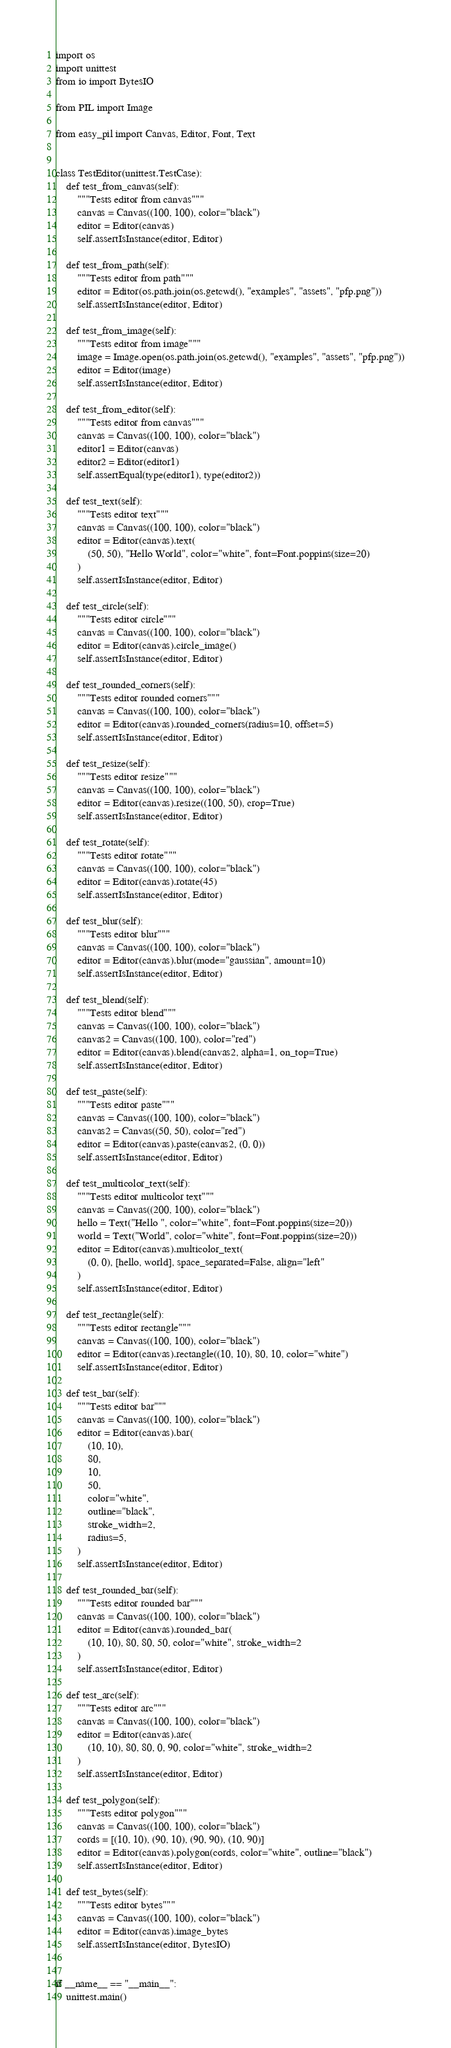Convert code to text. <code><loc_0><loc_0><loc_500><loc_500><_Python_>import os
import unittest
from io import BytesIO

from PIL import Image

from easy_pil import Canvas, Editor, Font, Text


class TestEditor(unittest.TestCase):
    def test_from_canvas(self):
        """Tests editor from canvas"""
        canvas = Canvas((100, 100), color="black")
        editor = Editor(canvas)
        self.assertIsInstance(editor, Editor)

    def test_from_path(self):
        """Tests editor from path"""
        editor = Editor(os.path.join(os.getcwd(), "examples", "assets", "pfp.png"))
        self.assertIsInstance(editor, Editor)

    def test_from_image(self):
        """Tests editor from image"""
        image = Image.open(os.path.join(os.getcwd(), "examples", "assets", "pfp.png"))
        editor = Editor(image)
        self.assertIsInstance(editor, Editor)

    def test_from_editor(self):
        """Tests editor from canvas"""
        canvas = Canvas((100, 100), color="black")
        editor1 = Editor(canvas)
        editor2 = Editor(editor1)
        self.assertEqual(type(editor1), type(editor2))

    def test_text(self):
        """Tests editor text"""
        canvas = Canvas((100, 100), color="black")
        editor = Editor(canvas).text(
            (50, 50), "Hello World", color="white", font=Font.poppins(size=20)
        )
        self.assertIsInstance(editor, Editor)

    def test_circle(self):
        """Tests editor circle"""
        canvas = Canvas((100, 100), color="black")
        editor = Editor(canvas).circle_image()
        self.assertIsInstance(editor, Editor)

    def test_rounded_corners(self):
        """Tests editor rounded corners"""
        canvas = Canvas((100, 100), color="black")
        editor = Editor(canvas).rounded_corners(radius=10, offset=5)
        self.assertIsInstance(editor, Editor)

    def test_resize(self):
        """Tests editor resize"""
        canvas = Canvas((100, 100), color="black")
        editor = Editor(canvas).resize((100, 50), crop=True)
        self.assertIsInstance(editor, Editor)

    def test_rotate(self):
        """Tests editor rotate"""
        canvas = Canvas((100, 100), color="black")
        editor = Editor(canvas).rotate(45)
        self.assertIsInstance(editor, Editor)

    def test_blur(self):
        """Tests editor blur"""
        canvas = Canvas((100, 100), color="black")
        editor = Editor(canvas).blur(mode="gaussian", amount=10)
        self.assertIsInstance(editor, Editor)

    def test_blend(self):
        """Tests editor blend"""
        canvas = Canvas((100, 100), color="black")
        canvas2 = Canvas((100, 100), color="red")
        editor = Editor(canvas).blend(canvas2, alpha=1, on_top=True)
        self.assertIsInstance(editor, Editor)

    def test_paste(self):
        """Tests editor paste"""
        canvas = Canvas((100, 100), color="black")
        canvas2 = Canvas((50, 50), color="red")
        editor = Editor(canvas).paste(canvas2, (0, 0))
        self.assertIsInstance(editor, Editor)

    def test_multicolor_text(self):
        """Tests editor multicolor text"""
        canvas = Canvas((200, 100), color="black")
        hello = Text("Hello ", color="white", font=Font.poppins(size=20))
        world = Text("World", color="white", font=Font.poppins(size=20))
        editor = Editor(canvas).multicolor_text(
            (0, 0), [hello, world], space_separated=False, align="left"
        )
        self.assertIsInstance(editor, Editor)

    def test_rectangle(self):
        """Tests editor rectangle"""
        canvas = Canvas((100, 100), color="black")
        editor = Editor(canvas).rectangle((10, 10), 80, 10, color="white")
        self.assertIsInstance(editor, Editor)

    def test_bar(self):
        """Tests editor bar"""
        canvas = Canvas((100, 100), color="black")
        editor = Editor(canvas).bar(
            (10, 10),
            80,
            10,
            50,
            color="white",
            outline="black",
            stroke_width=2,
            radius=5,
        )
        self.assertIsInstance(editor, Editor)

    def test_rounded_bar(self):
        """Tests editor rounded bar"""
        canvas = Canvas((100, 100), color="black")
        editor = Editor(canvas).rounded_bar(
            (10, 10), 80, 80, 50, color="white", stroke_width=2
        )
        self.assertIsInstance(editor, Editor)

    def test_arc(self):
        """Tests editor arc"""
        canvas = Canvas((100, 100), color="black")
        editor = Editor(canvas).arc(
            (10, 10), 80, 80, 0, 90, color="white", stroke_width=2
        )
        self.assertIsInstance(editor, Editor)

    def test_polygon(self):
        """Tests editor polygon"""
        canvas = Canvas((100, 100), color="black")
        cords = [(10, 10), (90, 10), (90, 90), (10, 90)]
        editor = Editor(canvas).polygon(cords, color="white", outline="black")
        self.assertIsInstance(editor, Editor)

    def test_bytes(self):
        """Tests editor bytes"""
        canvas = Canvas((100, 100), color="black")
        editor = Editor(canvas).image_bytes
        self.assertIsInstance(editor, BytesIO)


if __name__ == "__main__":
    unittest.main()
</code> 